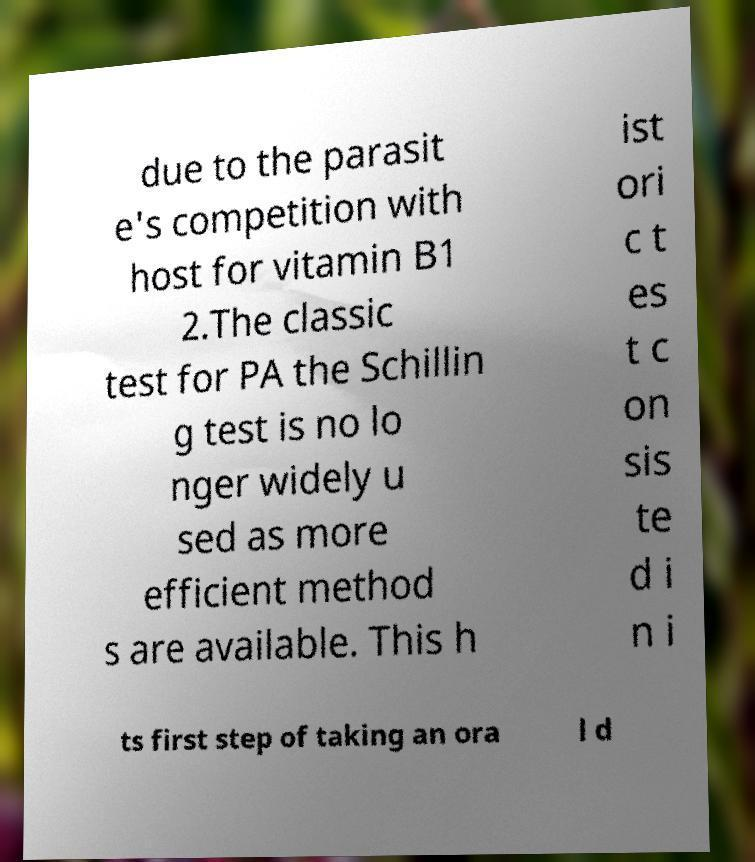There's text embedded in this image that I need extracted. Can you transcribe it verbatim? due to the parasit e's competition with host for vitamin B1 2.The classic test for PA the Schillin g test is no lo nger widely u sed as more efficient method s are available. This h ist ori c t es t c on sis te d i n i ts first step of taking an ora l d 